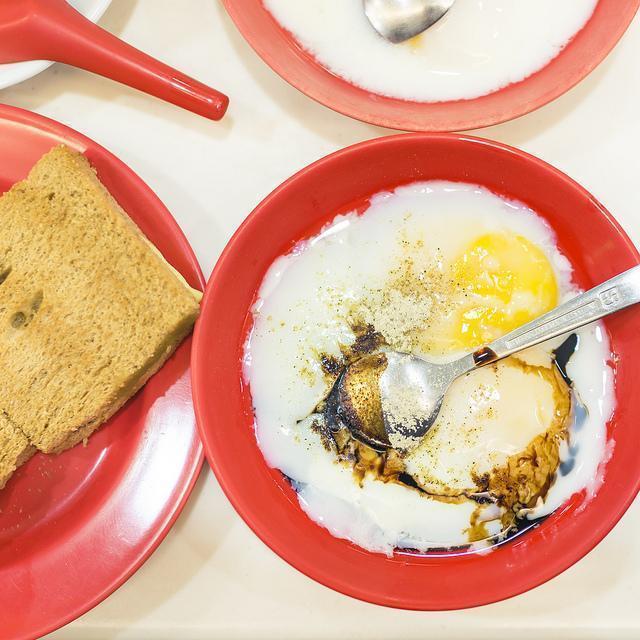Which food offers the most protein?
From the following four choices, select the correct answer to address the question.
Options: Ginger, pudding, bread, egg. Egg. 